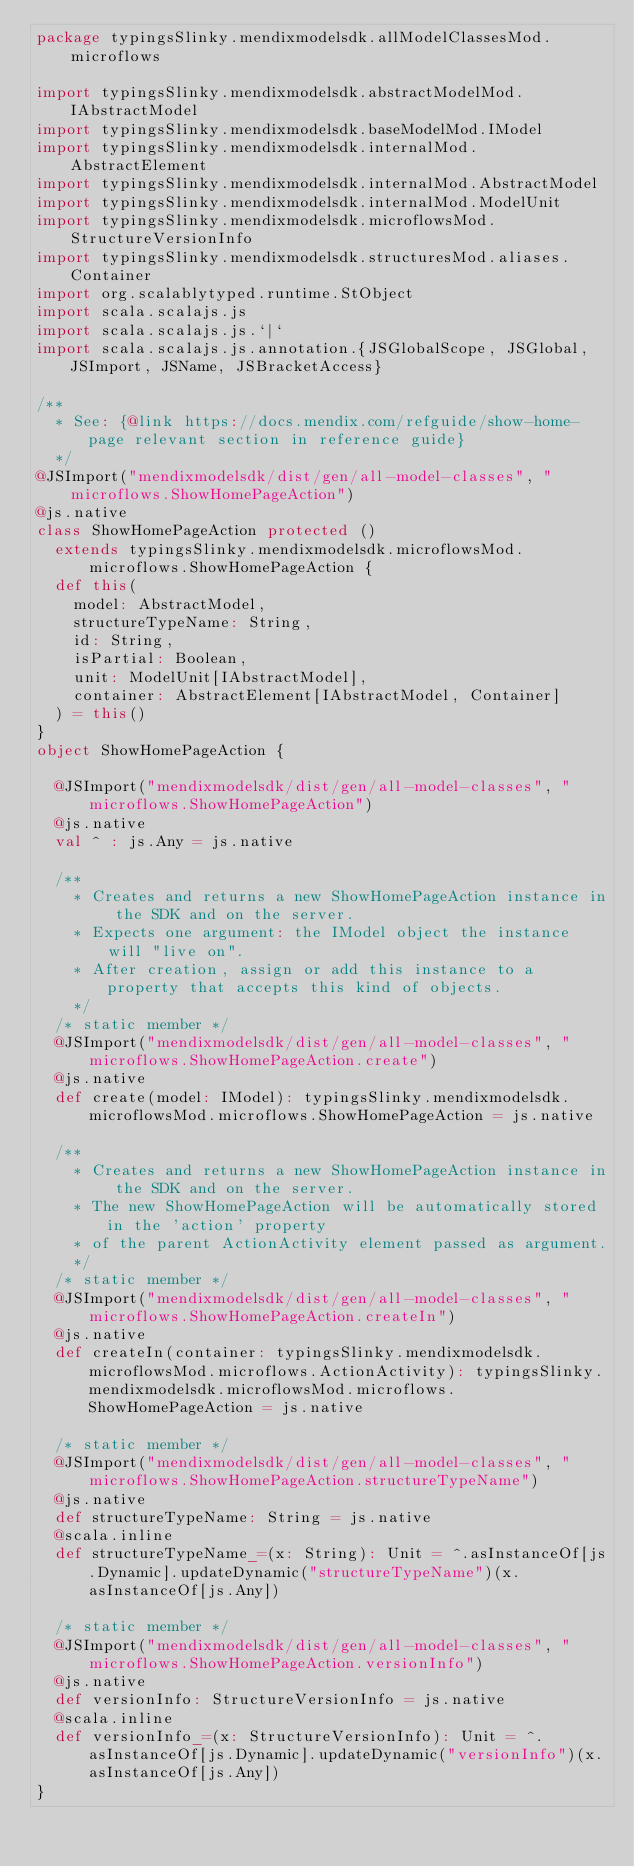Convert code to text. <code><loc_0><loc_0><loc_500><loc_500><_Scala_>package typingsSlinky.mendixmodelsdk.allModelClassesMod.microflows

import typingsSlinky.mendixmodelsdk.abstractModelMod.IAbstractModel
import typingsSlinky.mendixmodelsdk.baseModelMod.IModel
import typingsSlinky.mendixmodelsdk.internalMod.AbstractElement
import typingsSlinky.mendixmodelsdk.internalMod.AbstractModel
import typingsSlinky.mendixmodelsdk.internalMod.ModelUnit
import typingsSlinky.mendixmodelsdk.microflowsMod.StructureVersionInfo
import typingsSlinky.mendixmodelsdk.structuresMod.aliases.Container
import org.scalablytyped.runtime.StObject
import scala.scalajs.js
import scala.scalajs.js.`|`
import scala.scalajs.js.annotation.{JSGlobalScope, JSGlobal, JSImport, JSName, JSBracketAccess}

/**
  * See: {@link https://docs.mendix.com/refguide/show-home-page relevant section in reference guide}
  */
@JSImport("mendixmodelsdk/dist/gen/all-model-classes", "microflows.ShowHomePageAction")
@js.native
class ShowHomePageAction protected ()
  extends typingsSlinky.mendixmodelsdk.microflowsMod.microflows.ShowHomePageAction {
  def this(
    model: AbstractModel,
    structureTypeName: String,
    id: String,
    isPartial: Boolean,
    unit: ModelUnit[IAbstractModel],
    container: AbstractElement[IAbstractModel, Container]
  ) = this()
}
object ShowHomePageAction {
  
  @JSImport("mendixmodelsdk/dist/gen/all-model-classes", "microflows.ShowHomePageAction")
  @js.native
  val ^ : js.Any = js.native
  
  /**
    * Creates and returns a new ShowHomePageAction instance in the SDK and on the server.
    * Expects one argument: the IModel object the instance will "live on".
    * After creation, assign or add this instance to a property that accepts this kind of objects.
    */
  /* static member */
  @JSImport("mendixmodelsdk/dist/gen/all-model-classes", "microflows.ShowHomePageAction.create")
  @js.native
  def create(model: IModel): typingsSlinky.mendixmodelsdk.microflowsMod.microflows.ShowHomePageAction = js.native
  
  /**
    * Creates and returns a new ShowHomePageAction instance in the SDK and on the server.
    * The new ShowHomePageAction will be automatically stored in the 'action' property
    * of the parent ActionActivity element passed as argument.
    */
  /* static member */
  @JSImport("mendixmodelsdk/dist/gen/all-model-classes", "microflows.ShowHomePageAction.createIn")
  @js.native
  def createIn(container: typingsSlinky.mendixmodelsdk.microflowsMod.microflows.ActionActivity): typingsSlinky.mendixmodelsdk.microflowsMod.microflows.ShowHomePageAction = js.native
  
  /* static member */
  @JSImport("mendixmodelsdk/dist/gen/all-model-classes", "microflows.ShowHomePageAction.structureTypeName")
  @js.native
  def structureTypeName: String = js.native
  @scala.inline
  def structureTypeName_=(x: String): Unit = ^.asInstanceOf[js.Dynamic].updateDynamic("structureTypeName")(x.asInstanceOf[js.Any])
  
  /* static member */
  @JSImport("mendixmodelsdk/dist/gen/all-model-classes", "microflows.ShowHomePageAction.versionInfo")
  @js.native
  def versionInfo: StructureVersionInfo = js.native
  @scala.inline
  def versionInfo_=(x: StructureVersionInfo): Unit = ^.asInstanceOf[js.Dynamic].updateDynamic("versionInfo")(x.asInstanceOf[js.Any])
}
</code> 